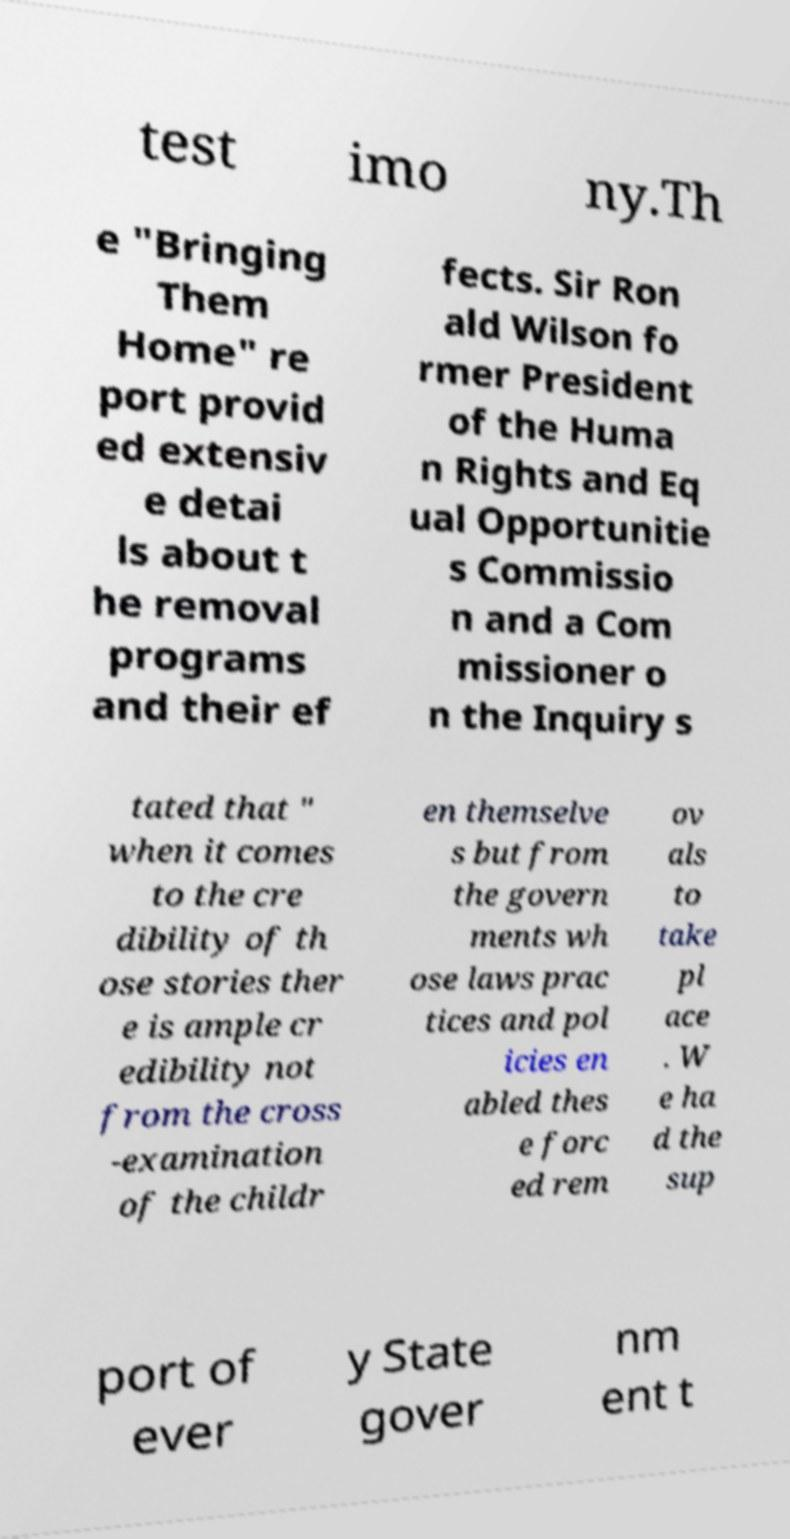For documentation purposes, I need the text within this image transcribed. Could you provide that? test imo ny.Th e "Bringing Them Home" re port provid ed extensiv e detai ls about t he removal programs and their ef fects. Sir Ron ald Wilson fo rmer President of the Huma n Rights and Eq ual Opportunitie s Commissio n and a Com missioner o n the Inquiry s tated that " when it comes to the cre dibility of th ose stories ther e is ample cr edibility not from the cross -examination of the childr en themselve s but from the govern ments wh ose laws prac tices and pol icies en abled thes e forc ed rem ov als to take pl ace . W e ha d the sup port of ever y State gover nm ent t 